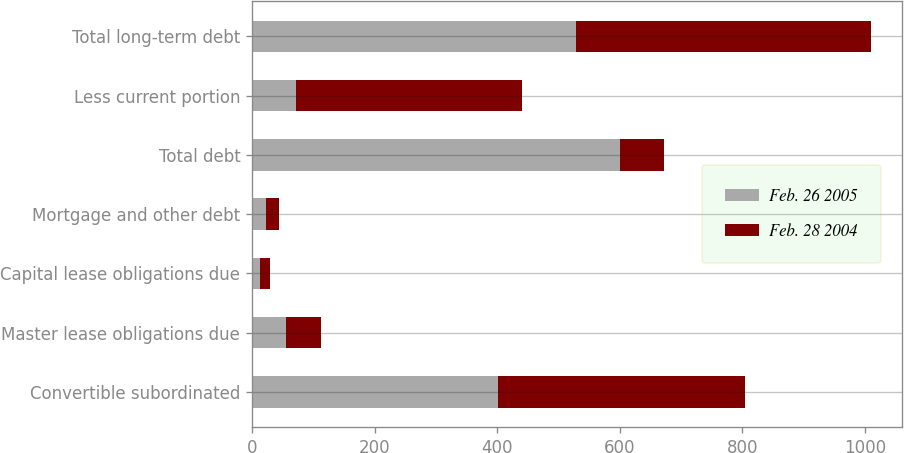<chart> <loc_0><loc_0><loc_500><loc_500><stacked_bar_chart><ecel><fcel>Convertible subordinated<fcel>Master lease obligations due<fcel>Capital lease obligations due<fcel>Mortgage and other debt<fcel>Total debt<fcel>Less current portion<fcel>Total long-term debt<nl><fcel>Feb. 26 2005<fcel>402<fcel>55<fcel>13<fcel>23<fcel>600<fcel>72<fcel>528<nl><fcel>Feb. 28 2004<fcel>402<fcel>58<fcel>16<fcel>21<fcel>72<fcel>368<fcel>482<nl></chart> 